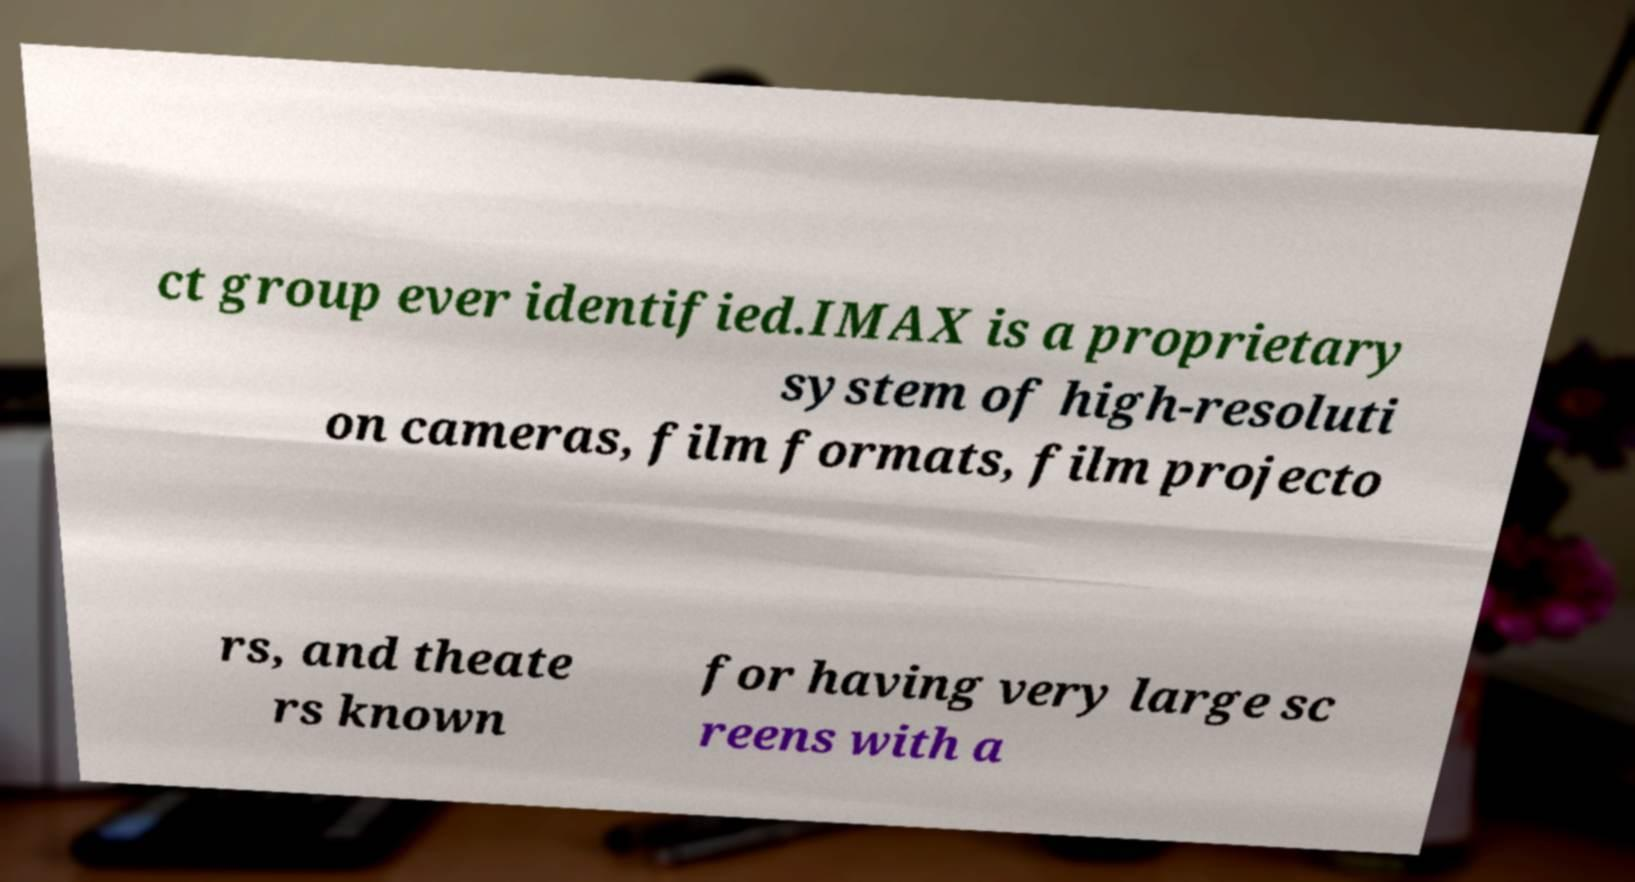Could you assist in decoding the text presented in this image and type it out clearly? ct group ever identified.IMAX is a proprietary system of high-resoluti on cameras, film formats, film projecto rs, and theate rs known for having very large sc reens with a 